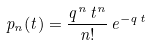Convert formula to latex. <formula><loc_0><loc_0><loc_500><loc_500>p _ { n } ( t ) = \frac { q ^ { n } \, t ^ { n } } { n ! } \, e ^ { - q \, t }</formula> 